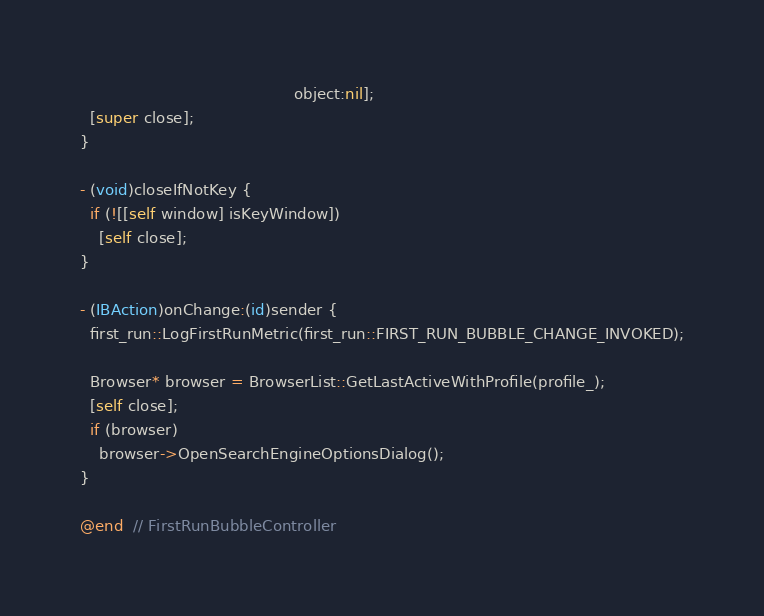Convert code to text. <code><loc_0><loc_0><loc_500><loc_500><_ObjectiveC_>                                             object:nil];
  [super close];
}

- (void)closeIfNotKey {
  if (![[self window] isKeyWindow])
    [self close];
}

- (IBAction)onChange:(id)sender {
  first_run::LogFirstRunMetric(first_run::FIRST_RUN_BUBBLE_CHANGE_INVOKED);

  Browser* browser = BrowserList::GetLastActiveWithProfile(profile_);
  [self close];
  if (browser)
    browser->OpenSearchEngineOptionsDialog();
}

@end  // FirstRunBubbleController
</code> 